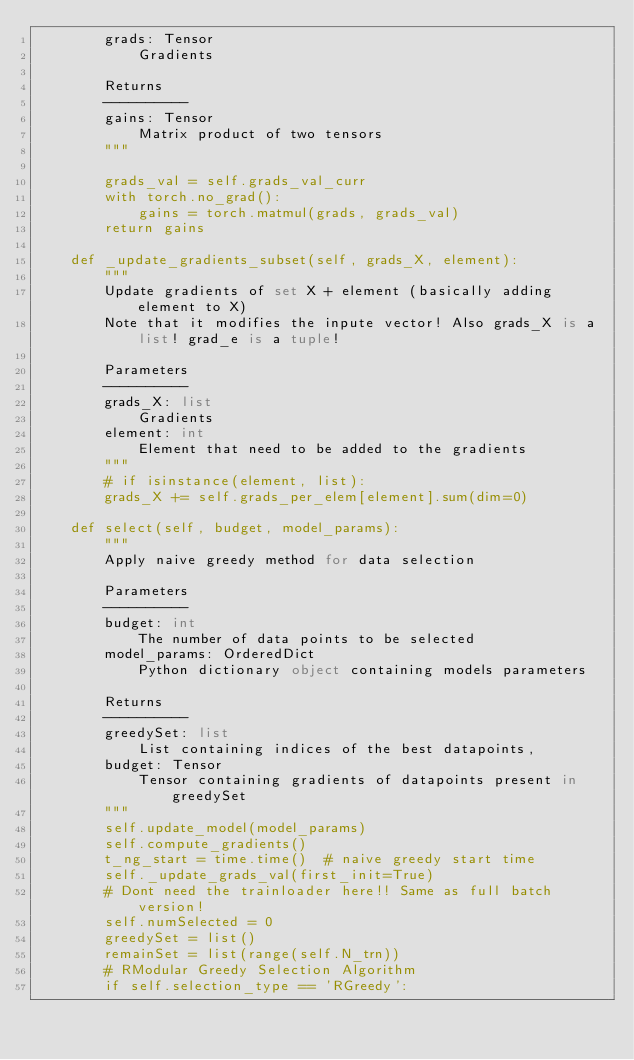<code> <loc_0><loc_0><loc_500><loc_500><_Python_>        grads: Tensor
            Gradients

        Returns
        ----------
        gains: Tensor
            Matrix product of two tensors
        """

        grads_val = self.grads_val_curr
        with torch.no_grad():
            gains = torch.matmul(grads, grads_val)
        return gains

    def _update_gradients_subset(self, grads_X, element):
        """
        Update gradients of set X + element (basically adding element to X)
        Note that it modifies the inpute vector! Also grads_X is a list! grad_e is a tuple!

        Parameters
        ----------
        grads_X: list
            Gradients
        element: int
            Element that need to be added to the gradients
        """
        # if isinstance(element, list):
        grads_X += self.grads_per_elem[element].sum(dim=0)

    def select(self, budget, model_params):
        """
        Apply naive greedy method for data selection

        Parameters
        ----------
        budget: int
            The number of data points to be selected
        model_params: OrderedDict
            Python dictionary object containing models parameters

        Returns
        ----------
        greedySet: list
            List containing indices of the best datapoints,
        budget: Tensor
            Tensor containing gradients of datapoints present in greedySet
        """
        self.update_model(model_params)
        self.compute_gradients()
        t_ng_start = time.time()  # naive greedy start time
        self._update_grads_val(first_init=True)
        # Dont need the trainloader here!! Same as full batch version!
        self.numSelected = 0
        greedySet = list()
        remainSet = list(range(self.N_trn))
        # RModular Greedy Selection Algorithm
        if self.selection_type == 'RGreedy':</code> 